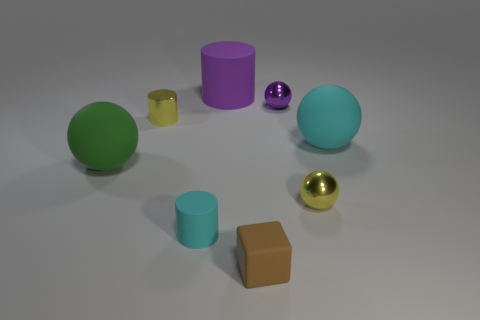Add 2 matte cylinders. How many objects exist? 10 Subtract all cubes. How many objects are left? 7 Subtract all yellow balls. Subtract all small cubes. How many objects are left? 6 Add 2 tiny yellow things. How many tiny yellow things are left? 4 Add 7 tiny purple things. How many tiny purple things exist? 8 Subtract 0 green cylinders. How many objects are left? 8 